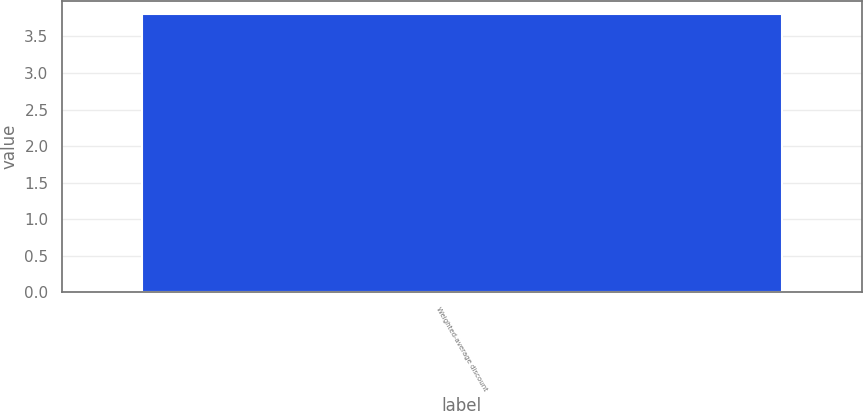Convert chart to OTSL. <chart><loc_0><loc_0><loc_500><loc_500><bar_chart><fcel>Weighted-average discount<nl><fcel>3.8<nl></chart> 